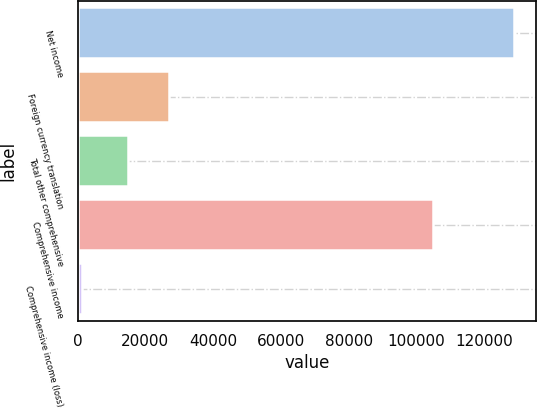Convert chart to OTSL. <chart><loc_0><loc_0><loc_500><loc_500><bar_chart><fcel>Net income<fcel>Foreign currency translation<fcel>Total other comprehensive<fcel>Comprehensive income<fcel>Comprehensive income (loss)<nl><fcel>128814<fcel>26959.6<fcel>14977<fcel>104849<fcel>1183<nl></chart> 